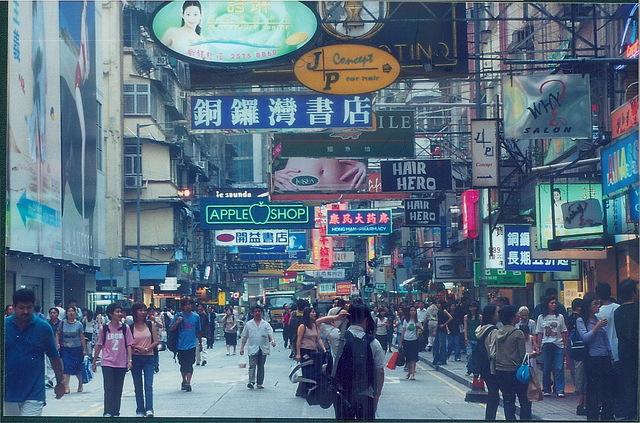Please transcribe the text information in this image. APPLE SHOP HERO HAIR HERO P SALON WHY ILE P J 